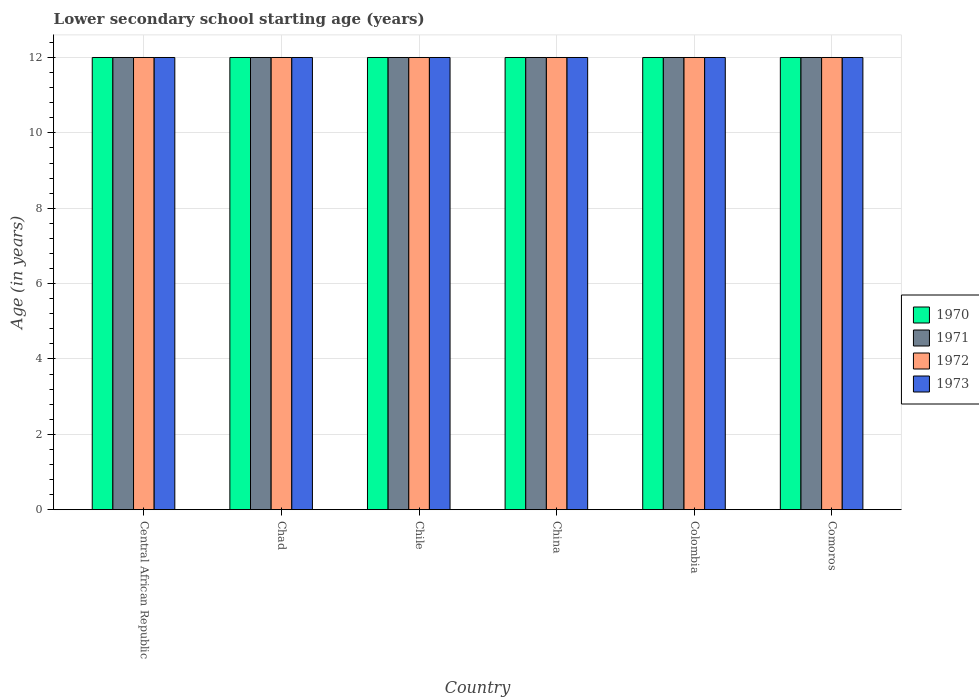Are the number of bars per tick equal to the number of legend labels?
Offer a very short reply. Yes. How many bars are there on the 2nd tick from the left?
Ensure brevity in your answer.  4. What is the label of the 4th group of bars from the left?
Make the answer very short. China. What is the lower secondary school starting age of children in 1972 in Chad?
Offer a very short reply. 12. Across all countries, what is the maximum lower secondary school starting age of children in 1973?
Provide a succinct answer. 12. In which country was the lower secondary school starting age of children in 1971 maximum?
Your response must be concise. Central African Republic. In which country was the lower secondary school starting age of children in 1973 minimum?
Make the answer very short. Central African Republic. What is the total lower secondary school starting age of children in 1972 in the graph?
Give a very brief answer. 72. What is the difference between the lower secondary school starting age of children in 1972 in Chile and the lower secondary school starting age of children in 1971 in China?
Provide a short and direct response. 0. What is the difference between the lower secondary school starting age of children of/in 1970 and lower secondary school starting age of children of/in 1973 in Colombia?
Offer a terse response. 0. What is the ratio of the lower secondary school starting age of children in 1973 in Chad to that in Comoros?
Provide a short and direct response. 1. Is the lower secondary school starting age of children in 1972 in Colombia less than that in Comoros?
Your answer should be compact. No. Is the difference between the lower secondary school starting age of children in 1970 in Chad and Comoros greater than the difference between the lower secondary school starting age of children in 1973 in Chad and Comoros?
Your answer should be very brief. No. What is the difference between the highest and the lowest lower secondary school starting age of children in 1972?
Make the answer very short. 0. In how many countries, is the lower secondary school starting age of children in 1972 greater than the average lower secondary school starting age of children in 1972 taken over all countries?
Provide a succinct answer. 0. Is the sum of the lower secondary school starting age of children in 1973 in Chile and China greater than the maximum lower secondary school starting age of children in 1972 across all countries?
Your response must be concise. Yes. How many bars are there?
Make the answer very short. 24. Are all the bars in the graph horizontal?
Provide a succinct answer. No. How many countries are there in the graph?
Your response must be concise. 6. What is the difference between two consecutive major ticks on the Y-axis?
Ensure brevity in your answer.  2. Does the graph contain any zero values?
Make the answer very short. No. Does the graph contain grids?
Your answer should be very brief. Yes. How many legend labels are there?
Provide a short and direct response. 4. How are the legend labels stacked?
Ensure brevity in your answer.  Vertical. What is the title of the graph?
Provide a succinct answer. Lower secondary school starting age (years). Does "1964" appear as one of the legend labels in the graph?
Ensure brevity in your answer.  No. What is the label or title of the X-axis?
Make the answer very short. Country. What is the label or title of the Y-axis?
Your answer should be compact. Age (in years). What is the Age (in years) of 1971 in Central African Republic?
Provide a short and direct response. 12. What is the Age (in years) of 1970 in Chad?
Make the answer very short. 12. What is the Age (in years) of 1971 in Chad?
Provide a succinct answer. 12. What is the Age (in years) of 1972 in Chad?
Provide a short and direct response. 12. What is the Age (in years) of 1973 in Chad?
Give a very brief answer. 12. What is the Age (in years) of 1970 in Chile?
Offer a terse response. 12. What is the Age (in years) of 1972 in Chile?
Provide a short and direct response. 12. What is the Age (in years) in 1973 in Chile?
Your answer should be compact. 12. What is the Age (in years) of 1972 in China?
Your response must be concise. 12. What is the Age (in years) in 1973 in China?
Your answer should be very brief. 12. What is the Age (in years) in 1970 in Colombia?
Make the answer very short. 12. What is the Age (in years) of 1972 in Colombia?
Provide a short and direct response. 12. What is the Age (in years) in 1973 in Comoros?
Keep it short and to the point. 12. Across all countries, what is the maximum Age (in years) in 1970?
Provide a short and direct response. 12. Across all countries, what is the maximum Age (in years) in 1971?
Make the answer very short. 12. Across all countries, what is the minimum Age (in years) of 1970?
Your answer should be very brief. 12. Across all countries, what is the minimum Age (in years) of 1971?
Your answer should be very brief. 12. Across all countries, what is the minimum Age (in years) in 1972?
Your answer should be very brief. 12. What is the total Age (in years) in 1970 in the graph?
Provide a short and direct response. 72. What is the total Age (in years) in 1971 in the graph?
Provide a succinct answer. 72. What is the total Age (in years) of 1973 in the graph?
Offer a terse response. 72. What is the difference between the Age (in years) of 1971 in Central African Republic and that in Chile?
Offer a very short reply. 0. What is the difference between the Age (in years) of 1973 in Central African Republic and that in Chile?
Your answer should be compact. 0. What is the difference between the Age (in years) of 1970 in Central African Republic and that in China?
Provide a succinct answer. 0. What is the difference between the Age (in years) in 1971 in Central African Republic and that in China?
Give a very brief answer. 0. What is the difference between the Age (in years) in 1973 in Central African Republic and that in China?
Keep it short and to the point. 0. What is the difference between the Age (in years) in 1971 in Central African Republic and that in Colombia?
Your answer should be very brief. 0. What is the difference between the Age (in years) of 1972 in Central African Republic and that in Comoros?
Your answer should be compact. 0. What is the difference between the Age (in years) in 1973 in Central African Republic and that in Comoros?
Provide a short and direct response. 0. What is the difference between the Age (in years) of 1972 in Chad and that in Chile?
Offer a terse response. 0. What is the difference between the Age (in years) in 1970 in Chad and that in China?
Your answer should be compact. 0. What is the difference between the Age (in years) in 1971 in Chad and that in China?
Provide a short and direct response. 0. What is the difference between the Age (in years) of 1973 in Chad and that in China?
Offer a terse response. 0. What is the difference between the Age (in years) of 1971 in Chad and that in Colombia?
Provide a short and direct response. 0. What is the difference between the Age (in years) of 1973 in Chad and that in Colombia?
Your answer should be compact. 0. What is the difference between the Age (in years) in 1970 in Chad and that in Comoros?
Offer a terse response. 0. What is the difference between the Age (in years) in 1971 in Chad and that in Comoros?
Your answer should be compact. 0. What is the difference between the Age (in years) in 1972 in Chad and that in Comoros?
Offer a terse response. 0. What is the difference between the Age (in years) of 1973 in Chile and that in China?
Give a very brief answer. 0. What is the difference between the Age (in years) of 1972 in Chile and that in Colombia?
Your response must be concise. 0. What is the difference between the Age (in years) in 1973 in Chile and that in Colombia?
Keep it short and to the point. 0. What is the difference between the Age (in years) of 1970 in Chile and that in Comoros?
Your answer should be compact. 0. What is the difference between the Age (in years) in 1972 in Chile and that in Comoros?
Provide a short and direct response. 0. What is the difference between the Age (in years) in 1972 in China and that in Colombia?
Provide a succinct answer. 0. What is the difference between the Age (in years) in 1970 in China and that in Comoros?
Your answer should be compact. 0. What is the difference between the Age (in years) of 1971 in China and that in Comoros?
Provide a short and direct response. 0. What is the difference between the Age (in years) of 1972 in China and that in Comoros?
Give a very brief answer. 0. What is the difference between the Age (in years) of 1970 in Colombia and that in Comoros?
Make the answer very short. 0. What is the difference between the Age (in years) of 1970 in Central African Republic and the Age (in years) of 1971 in Chad?
Provide a short and direct response. 0. What is the difference between the Age (in years) of 1972 in Central African Republic and the Age (in years) of 1973 in Chad?
Offer a very short reply. 0. What is the difference between the Age (in years) of 1970 in Central African Republic and the Age (in years) of 1973 in Chile?
Keep it short and to the point. 0. What is the difference between the Age (in years) in 1970 in Central African Republic and the Age (in years) in 1971 in China?
Your answer should be very brief. 0. What is the difference between the Age (in years) in 1970 in Central African Republic and the Age (in years) in 1972 in China?
Keep it short and to the point. 0. What is the difference between the Age (in years) in 1970 in Central African Republic and the Age (in years) in 1973 in China?
Your response must be concise. 0. What is the difference between the Age (in years) of 1971 in Central African Republic and the Age (in years) of 1972 in China?
Your answer should be compact. 0. What is the difference between the Age (in years) in 1972 in Central African Republic and the Age (in years) in 1973 in China?
Your answer should be very brief. 0. What is the difference between the Age (in years) of 1970 in Central African Republic and the Age (in years) of 1973 in Colombia?
Keep it short and to the point. 0. What is the difference between the Age (in years) of 1970 in Central African Republic and the Age (in years) of 1971 in Comoros?
Your answer should be compact. 0. What is the difference between the Age (in years) in 1970 in Central African Republic and the Age (in years) in 1972 in Comoros?
Your answer should be very brief. 0. What is the difference between the Age (in years) of 1970 in Central African Republic and the Age (in years) of 1973 in Comoros?
Your answer should be compact. 0. What is the difference between the Age (in years) in 1971 in Central African Republic and the Age (in years) in 1972 in Comoros?
Offer a very short reply. 0. What is the difference between the Age (in years) in 1971 in Central African Republic and the Age (in years) in 1973 in Comoros?
Provide a short and direct response. 0. What is the difference between the Age (in years) in 1972 in Chad and the Age (in years) in 1973 in Chile?
Make the answer very short. 0. What is the difference between the Age (in years) of 1970 in Chad and the Age (in years) of 1971 in China?
Provide a succinct answer. 0. What is the difference between the Age (in years) in 1970 in Chad and the Age (in years) in 1972 in China?
Offer a terse response. 0. What is the difference between the Age (in years) in 1970 in Chad and the Age (in years) in 1973 in China?
Your answer should be very brief. 0. What is the difference between the Age (in years) in 1971 in Chad and the Age (in years) in 1972 in China?
Offer a terse response. 0. What is the difference between the Age (in years) of 1972 in Chad and the Age (in years) of 1973 in China?
Your response must be concise. 0. What is the difference between the Age (in years) of 1970 in Chad and the Age (in years) of 1971 in Colombia?
Give a very brief answer. 0. What is the difference between the Age (in years) of 1971 in Chad and the Age (in years) of 1972 in Colombia?
Make the answer very short. 0. What is the difference between the Age (in years) in 1970 in Chad and the Age (in years) in 1972 in Comoros?
Your response must be concise. 0. What is the difference between the Age (in years) in 1972 in Chad and the Age (in years) in 1973 in Comoros?
Offer a very short reply. 0. What is the difference between the Age (in years) in 1970 in Chile and the Age (in years) in 1972 in China?
Your response must be concise. 0. What is the difference between the Age (in years) of 1970 in Chile and the Age (in years) of 1973 in China?
Make the answer very short. 0. What is the difference between the Age (in years) in 1972 in Chile and the Age (in years) in 1973 in China?
Keep it short and to the point. 0. What is the difference between the Age (in years) in 1970 in Chile and the Age (in years) in 1972 in Colombia?
Ensure brevity in your answer.  0. What is the difference between the Age (in years) of 1971 in Chile and the Age (in years) of 1972 in Colombia?
Provide a short and direct response. 0. What is the difference between the Age (in years) of 1970 in Chile and the Age (in years) of 1973 in Comoros?
Your response must be concise. 0. What is the difference between the Age (in years) of 1971 in China and the Age (in years) of 1973 in Colombia?
Make the answer very short. 0. What is the difference between the Age (in years) of 1972 in China and the Age (in years) of 1973 in Colombia?
Give a very brief answer. 0. What is the difference between the Age (in years) of 1970 in China and the Age (in years) of 1973 in Comoros?
Your answer should be compact. 0. What is the difference between the Age (in years) of 1971 in China and the Age (in years) of 1972 in Comoros?
Provide a succinct answer. 0. What is the difference between the Age (in years) in 1971 in China and the Age (in years) in 1973 in Comoros?
Make the answer very short. 0. What is the difference between the Age (in years) of 1970 in Colombia and the Age (in years) of 1971 in Comoros?
Your response must be concise. 0. What is the difference between the Age (in years) of 1971 in Colombia and the Age (in years) of 1972 in Comoros?
Provide a succinct answer. 0. What is the difference between the Age (in years) in 1971 in Colombia and the Age (in years) in 1973 in Comoros?
Offer a very short reply. 0. What is the difference between the Age (in years) in 1972 in Colombia and the Age (in years) in 1973 in Comoros?
Offer a terse response. 0. What is the average Age (in years) of 1970 per country?
Offer a very short reply. 12. What is the average Age (in years) in 1972 per country?
Your response must be concise. 12. What is the difference between the Age (in years) in 1970 and Age (in years) in 1971 in Central African Republic?
Make the answer very short. 0. What is the difference between the Age (in years) of 1970 and Age (in years) of 1972 in Central African Republic?
Ensure brevity in your answer.  0. What is the difference between the Age (in years) of 1970 and Age (in years) of 1973 in Central African Republic?
Give a very brief answer. 0. What is the difference between the Age (in years) of 1971 and Age (in years) of 1972 in Central African Republic?
Your answer should be compact. 0. What is the difference between the Age (in years) of 1971 and Age (in years) of 1973 in Central African Republic?
Your answer should be compact. 0. What is the difference between the Age (in years) in 1972 and Age (in years) in 1973 in Central African Republic?
Ensure brevity in your answer.  0. What is the difference between the Age (in years) of 1970 and Age (in years) of 1973 in Chad?
Ensure brevity in your answer.  0. What is the difference between the Age (in years) in 1971 and Age (in years) in 1972 in Chad?
Provide a short and direct response. 0. What is the difference between the Age (in years) in 1972 and Age (in years) in 1973 in Chad?
Your response must be concise. 0. What is the difference between the Age (in years) of 1970 and Age (in years) of 1971 in Chile?
Provide a short and direct response. 0. What is the difference between the Age (in years) of 1970 and Age (in years) of 1973 in Chile?
Give a very brief answer. 0. What is the difference between the Age (in years) of 1971 and Age (in years) of 1972 in Chile?
Keep it short and to the point. 0. What is the difference between the Age (in years) in 1970 and Age (in years) in 1971 in China?
Your answer should be very brief. 0. What is the difference between the Age (in years) of 1970 and Age (in years) of 1972 in China?
Provide a succinct answer. 0. What is the difference between the Age (in years) of 1970 and Age (in years) of 1973 in China?
Give a very brief answer. 0. What is the difference between the Age (in years) of 1971 and Age (in years) of 1972 in China?
Keep it short and to the point. 0. What is the difference between the Age (in years) of 1971 and Age (in years) of 1973 in China?
Provide a short and direct response. 0. What is the difference between the Age (in years) of 1972 and Age (in years) of 1973 in China?
Ensure brevity in your answer.  0. What is the difference between the Age (in years) of 1970 and Age (in years) of 1971 in Colombia?
Your answer should be compact. 0. What is the difference between the Age (in years) of 1970 and Age (in years) of 1972 in Colombia?
Ensure brevity in your answer.  0. What is the difference between the Age (in years) in 1971 and Age (in years) in 1972 in Colombia?
Ensure brevity in your answer.  0. What is the difference between the Age (in years) of 1971 and Age (in years) of 1973 in Colombia?
Make the answer very short. 0. What is the difference between the Age (in years) in 1970 and Age (in years) in 1971 in Comoros?
Provide a short and direct response. 0. What is the difference between the Age (in years) of 1971 and Age (in years) of 1972 in Comoros?
Ensure brevity in your answer.  0. What is the difference between the Age (in years) in 1971 and Age (in years) in 1973 in Comoros?
Your response must be concise. 0. What is the difference between the Age (in years) of 1972 and Age (in years) of 1973 in Comoros?
Give a very brief answer. 0. What is the ratio of the Age (in years) of 1970 in Central African Republic to that in Chad?
Keep it short and to the point. 1. What is the ratio of the Age (in years) of 1973 in Central African Republic to that in Chad?
Offer a very short reply. 1. What is the ratio of the Age (in years) of 1971 in Central African Republic to that in Chile?
Your answer should be compact. 1. What is the ratio of the Age (in years) of 1972 in Central African Republic to that in Chile?
Keep it short and to the point. 1. What is the ratio of the Age (in years) of 1970 in Central African Republic to that in China?
Ensure brevity in your answer.  1. What is the ratio of the Age (in years) of 1971 in Central African Republic to that in China?
Offer a terse response. 1. What is the ratio of the Age (in years) in 1972 in Central African Republic to that in China?
Provide a succinct answer. 1. What is the ratio of the Age (in years) of 1971 in Central African Republic to that in Colombia?
Provide a short and direct response. 1. What is the ratio of the Age (in years) in 1970 in Central African Republic to that in Comoros?
Ensure brevity in your answer.  1. What is the ratio of the Age (in years) of 1971 in Central African Republic to that in Comoros?
Your answer should be very brief. 1. What is the ratio of the Age (in years) in 1970 in Chad to that in Chile?
Your response must be concise. 1. What is the ratio of the Age (in years) in 1971 in Chad to that in Chile?
Your answer should be compact. 1. What is the ratio of the Age (in years) in 1973 in Chad to that in Chile?
Provide a short and direct response. 1. What is the ratio of the Age (in years) in 1970 in Chad to that in China?
Offer a terse response. 1. What is the ratio of the Age (in years) of 1972 in Chad to that in China?
Offer a very short reply. 1. What is the ratio of the Age (in years) in 1971 in Chad to that in Colombia?
Offer a very short reply. 1. What is the ratio of the Age (in years) of 1972 in Chad to that in Colombia?
Make the answer very short. 1. What is the ratio of the Age (in years) of 1972 in Chad to that in Comoros?
Your response must be concise. 1. What is the ratio of the Age (in years) of 1971 in Chile to that in China?
Keep it short and to the point. 1. What is the ratio of the Age (in years) of 1972 in Chile to that in China?
Offer a terse response. 1. What is the ratio of the Age (in years) in 1973 in Chile to that in China?
Make the answer very short. 1. What is the ratio of the Age (in years) in 1972 in Chile to that in Comoros?
Provide a short and direct response. 1. What is the ratio of the Age (in years) in 1971 in China to that in Colombia?
Your answer should be very brief. 1. What is the ratio of the Age (in years) of 1972 in China to that in Colombia?
Offer a very short reply. 1. What is the ratio of the Age (in years) in 1971 in China to that in Comoros?
Provide a short and direct response. 1. What is the ratio of the Age (in years) of 1973 in China to that in Comoros?
Provide a succinct answer. 1. What is the ratio of the Age (in years) in 1972 in Colombia to that in Comoros?
Your response must be concise. 1. What is the difference between the highest and the second highest Age (in years) of 1970?
Offer a terse response. 0. What is the difference between the highest and the second highest Age (in years) of 1972?
Provide a short and direct response. 0. What is the difference between the highest and the second highest Age (in years) in 1973?
Provide a succinct answer. 0. 